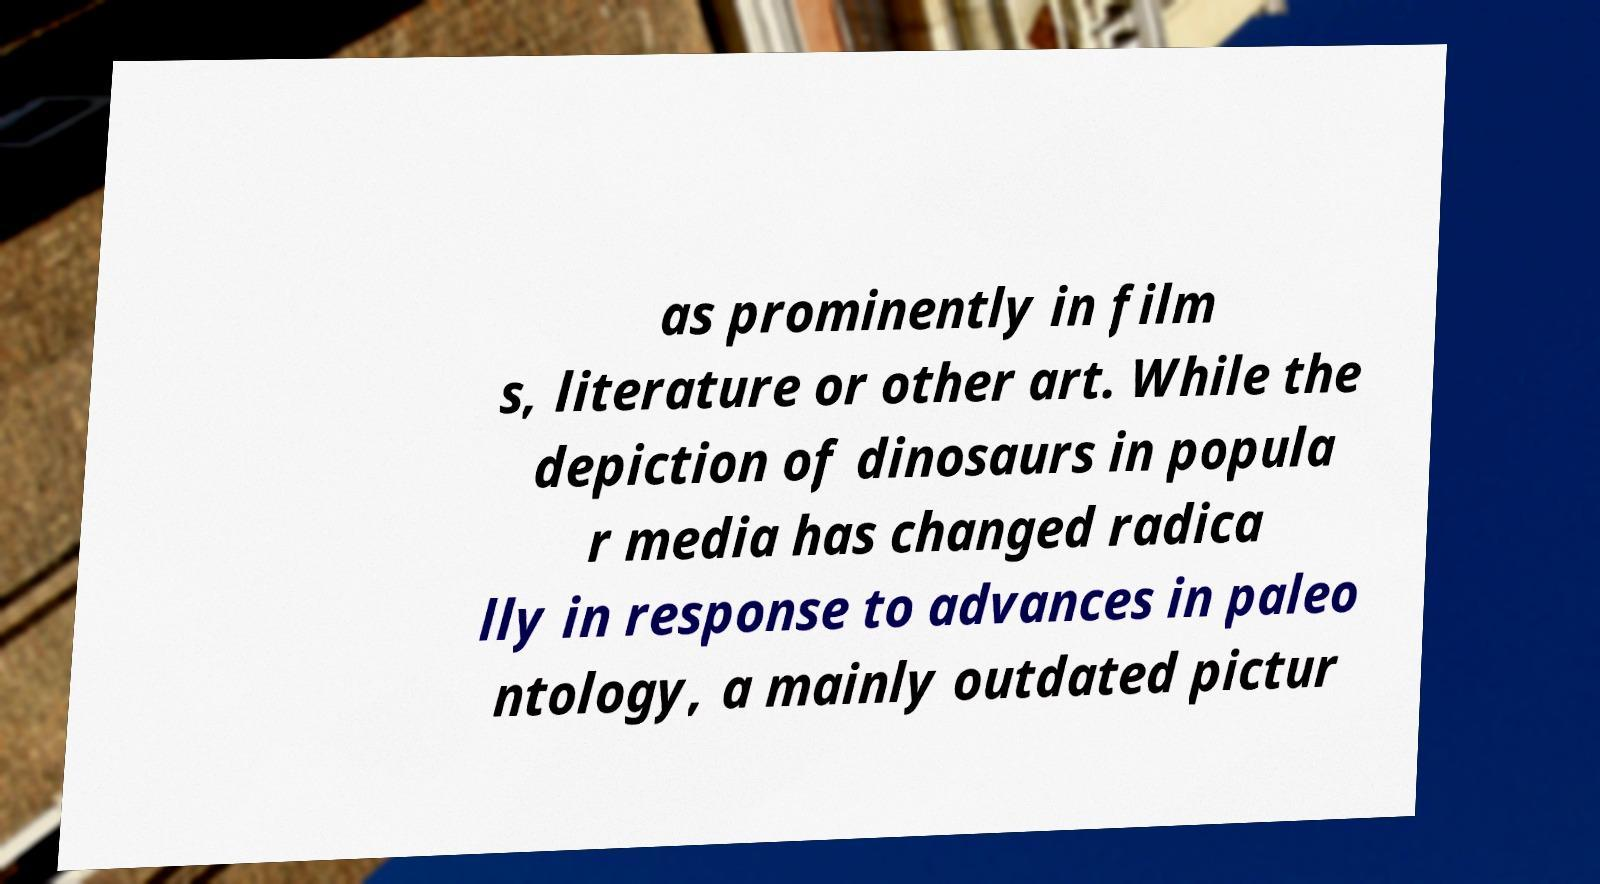What messages or text are displayed in this image? I need them in a readable, typed format. as prominently in film s, literature or other art. While the depiction of dinosaurs in popula r media has changed radica lly in response to advances in paleo ntology, a mainly outdated pictur 